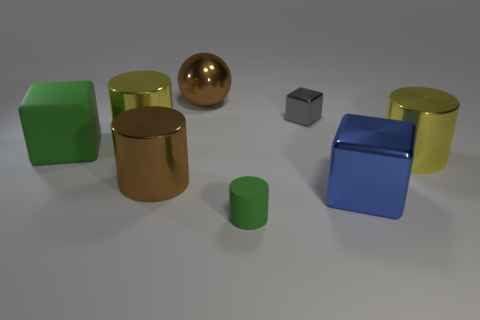Add 1 small gray objects. How many objects exist? 9 Subtract all spheres. How many objects are left? 7 Subtract 0 red cylinders. How many objects are left? 8 Subtract all brown shiny cylinders. Subtract all big blue metal things. How many objects are left? 6 Add 8 small green things. How many small green things are left? 9 Add 7 large brown cylinders. How many large brown cylinders exist? 8 